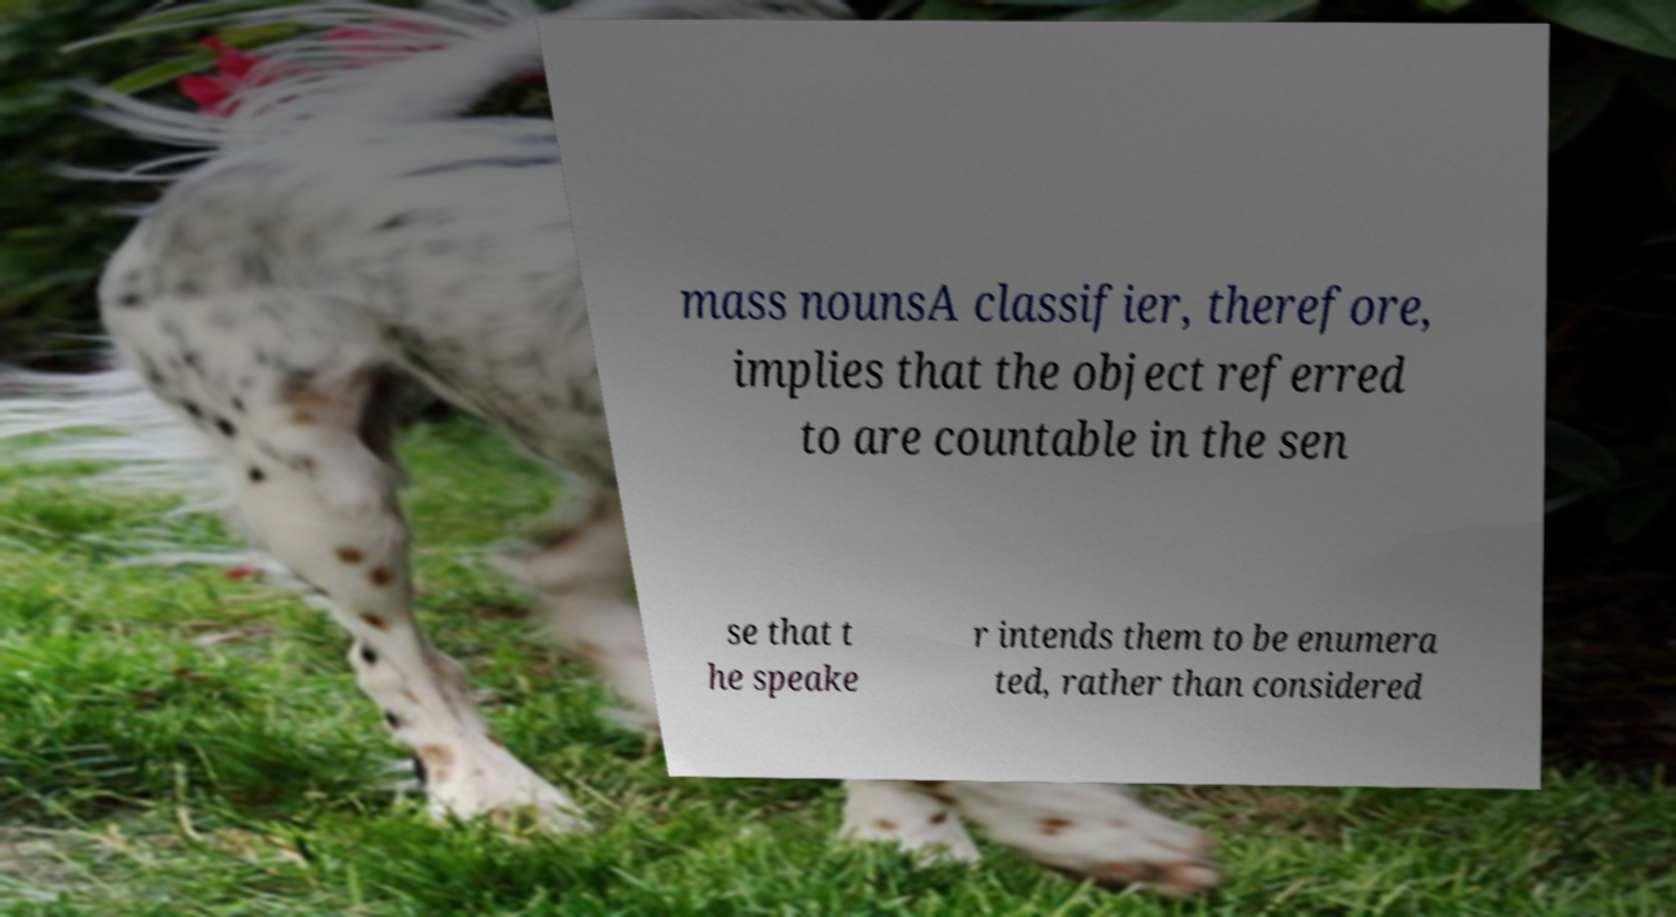Please read and relay the text visible in this image. What does it say? mass nounsA classifier, therefore, implies that the object referred to are countable in the sen se that t he speake r intends them to be enumera ted, rather than considered 